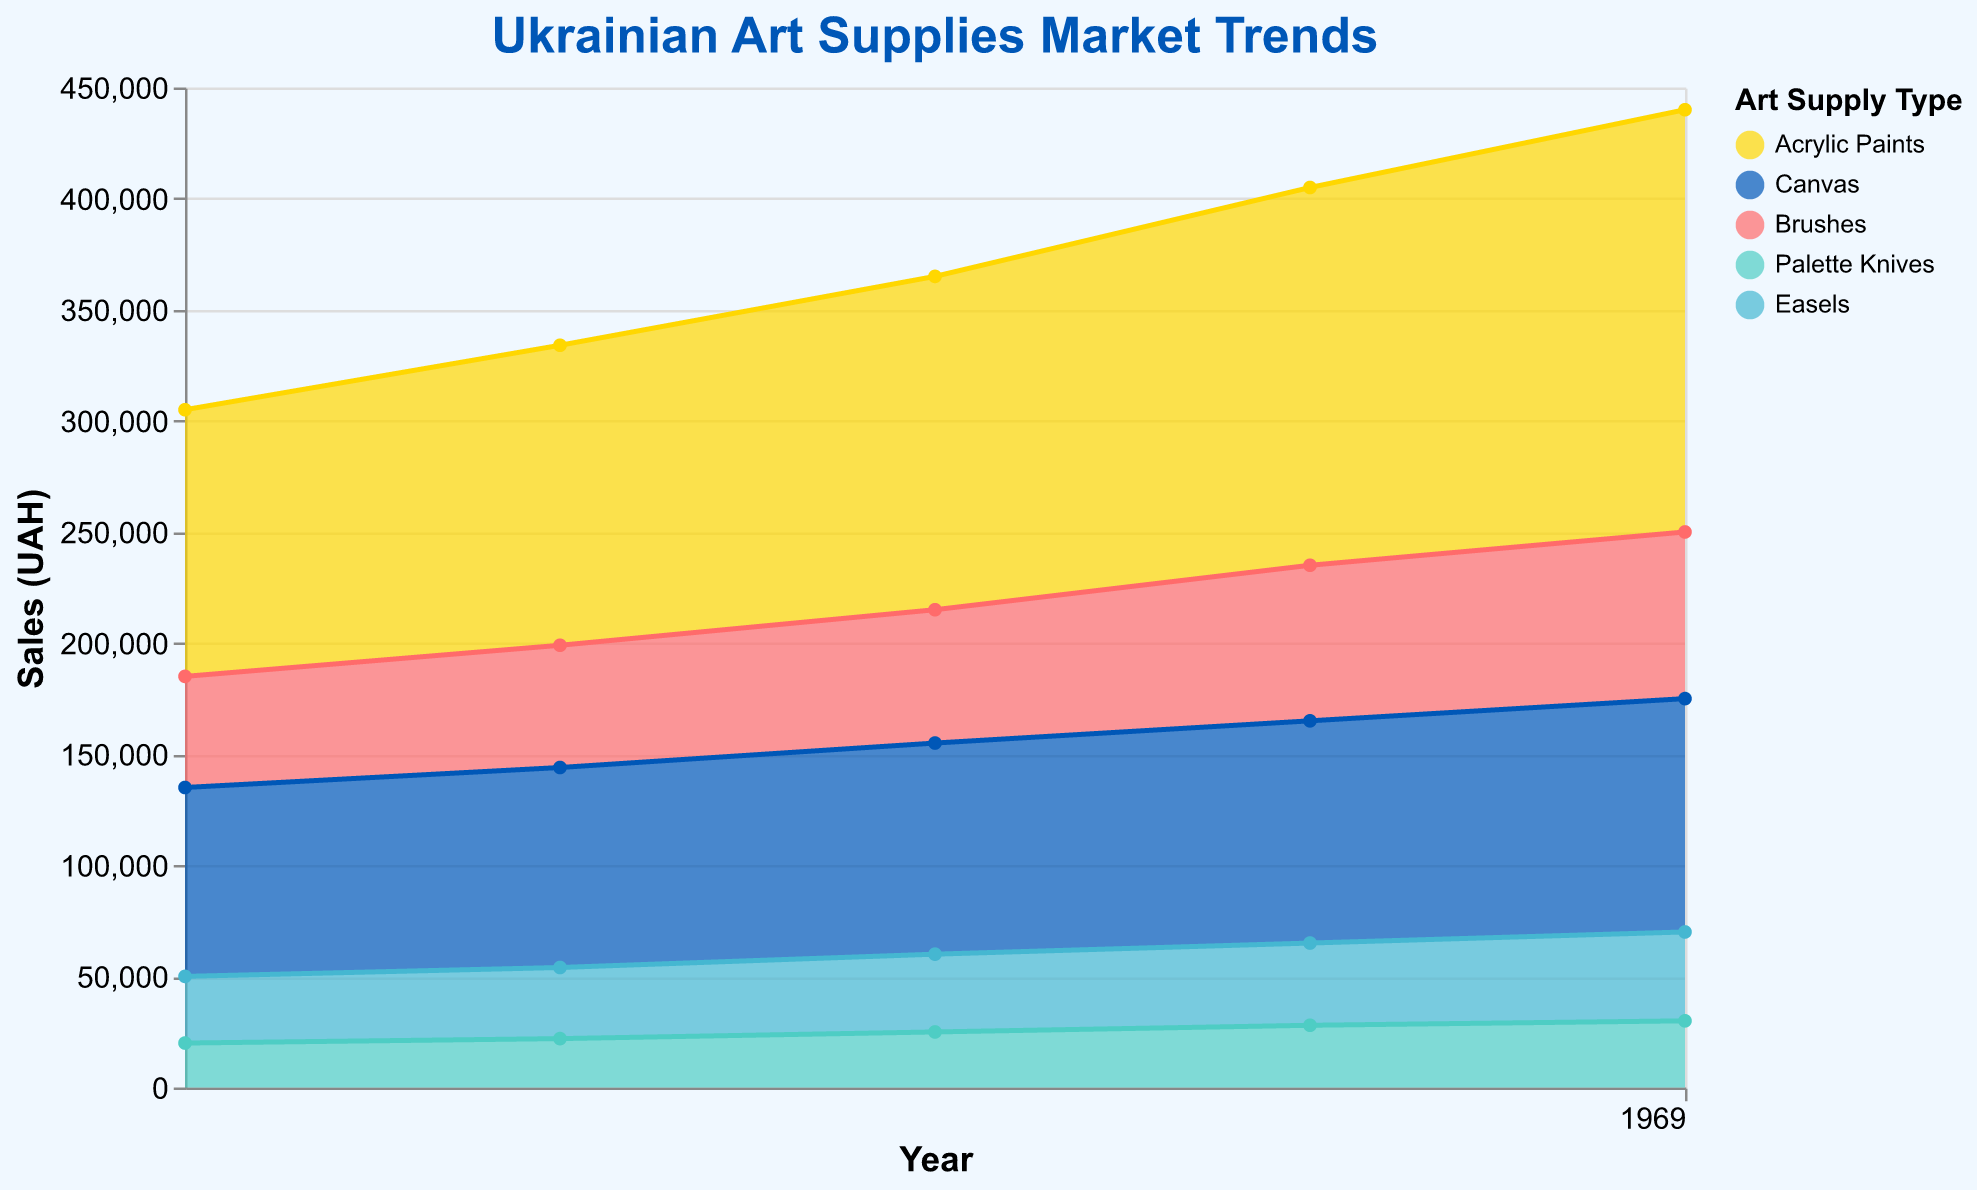What is the title of the chart? The title is at the top of the chart and reads "Ukrainian Art Supplies Market Trends."
Answer: Ukrainian Art Supplies Market Trends What is the highest sales figure for Acrylic Paints? Look for the highest point of the area corresponding to Acrylic Paints, which is color-coded in gold. The tooltip shows that in 2022, Acrylic Paints had the highest sales figure of 190,000 UAH.
Answer: 190,000 UAH Which art supply type had the lowest sales in 2018? In 2018, the lowest point corresponds to Palette Knives, as indicated by the area in light green. The tooltip confirms that Palette Knives had sales of 20,000 UAH in 2018.
Answer: Palette Knives How did the sales of Brushes change from 2018 to 2022? Track the area corresponding to Brushes (pink color) from 2018 to 2022. Sales increased from 50,000 UAH in 2018 to 75,000 UAH in 2022. Therefore, sales increased by 25,000 UAH over the period.
Answer: Increased by 25,000 UAH Which art supply type experienced the most growth from 2018 to 2022? By comparing the starting and ending points of each type's area, the largest increase appears in Acrylic Paints, growing from 120,000 UAH in 2018 to 190,000 UAH in 2022, an increase of 70,000 UAH.
Answer: Acrylic Paints Which year saw the highest total sales across all art supply types? To identify the year with the highest total sales, sum the sales for each year. 2022 has the highest total sales sum of (190,000 + 105,000 + 75,000 + 30,000 + 40,000) UAH = 440,000 UAH.
Answer: 2022 What is the color associated with Canvas sales? The color can be identified by looking at the area representing Canvas, which is blue.
Answer: Blue How did the sales for Easels change over the years shown in the chart? The sales of Easels are represented by the turquoise blue area. Tracking it from year to year: 30,000 UAH in 2018, 32,000 UAH in 2019, 35,000 UAH in 2020, 37,000 UAH in 2021, and 40,000 UAH in 2022, showing a gradual increase.
Answer: Gradual increase Which two years have identical sales figures for Palette Knives, and what are those figures? Check the area for Palette Knives in green. Both 2019 and 2021 have identical sales figures, each at 22,000 and 28,000 UAH respectively.
Answer: 2019 and 2021, 22,000 and 28,000 UAH 